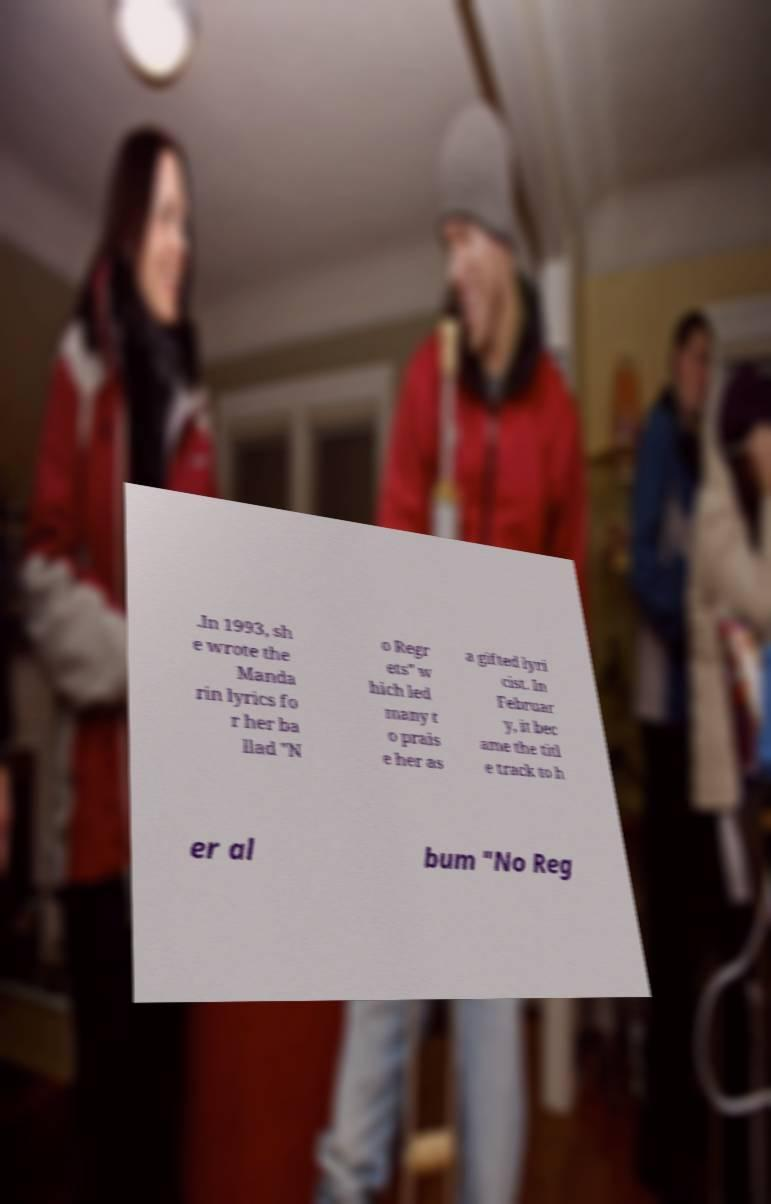There's text embedded in this image that I need extracted. Can you transcribe it verbatim? .In 1993, sh e wrote the Manda rin lyrics fo r her ba llad "N o Regr ets" w hich led many t o prais e her as a gifted lyri cist. In Februar y, it bec ame the titl e track to h er al bum "No Reg 